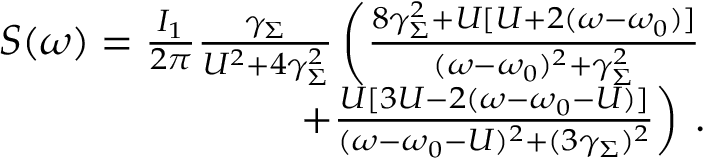Convert formula to latex. <formula><loc_0><loc_0><loc_500><loc_500>\begin{array} { r } { S ( \omega ) = \frac { I _ { 1 } } { 2 \pi } \frac { \gamma _ { \Sigma } } { U ^ { 2 } + 4 \gamma _ { \Sigma } ^ { 2 } } \left ( \frac { 8 \gamma _ { \Sigma } ^ { 2 } + U [ U + 2 ( \omega - \omega _ { 0 } ) ] } { ( \omega - \omega _ { 0 } ) ^ { 2 } + \gamma _ { \Sigma } ^ { 2 } } } \\ { + \frac { U [ 3 U - 2 ( \omega - \omega _ { 0 } - U ) ] } { ( \omega - \omega _ { 0 } - U ) ^ { 2 } + ( 3 \gamma _ { \Sigma } ) ^ { 2 } } \right ) \, . } \end{array}</formula> 